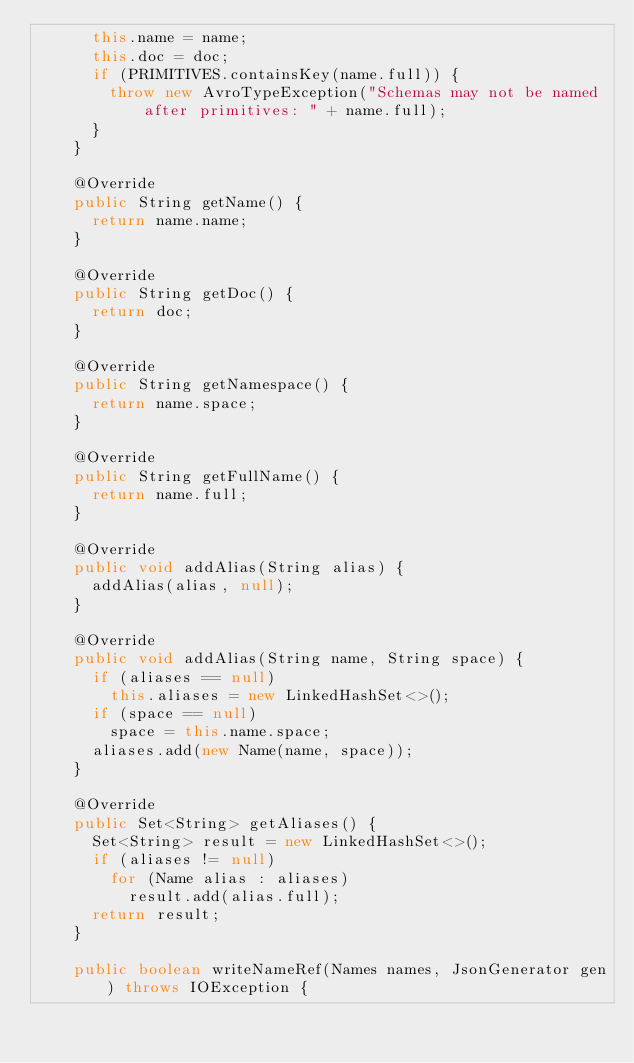<code> <loc_0><loc_0><loc_500><loc_500><_Java_>      this.name = name;
      this.doc = doc;
      if (PRIMITIVES.containsKey(name.full)) {
        throw new AvroTypeException("Schemas may not be named after primitives: " + name.full);
      }
    }

    @Override
    public String getName() {
      return name.name;
    }

    @Override
    public String getDoc() {
      return doc;
    }

    @Override
    public String getNamespace() {
      return name.space;
    }

    @Override
    public String getFullName() {
      return name.full;
    }

    @Override
    public void addAlias(String alias) {
      addAlias(alias, null);
    }

    @Override
    public void addAlias(String name, String space) {
      if (aliases == null)
        this.aliases = new LinkedHashSet<>();
      if (space == null)
        space = this.name.space;
      aliases.add(new Name(name, space));
    }

    @Override
    public Set<String> getAliases() {
      Set<String> result = new LinkedHashSet<>();
      if (aliases != null)
        for (Name alias : aliases)
          result.add(alias.full);
      return result;
    }

    public boolean writeNameRef(Names names, JsonGenerator gen) throws IOException {</code> 